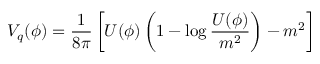<formula> <loc_0><loc_0><loc_500><loc_500>V _ { q } ( \phi ) = \frac { 1 } { 8 \pi } \left [ U ( \phi ) \left ( 1 - \log \frac { U ( \phi ) } { m ^ { 2 } } \right ) - m ^ { 2 } \right ]</formula> 